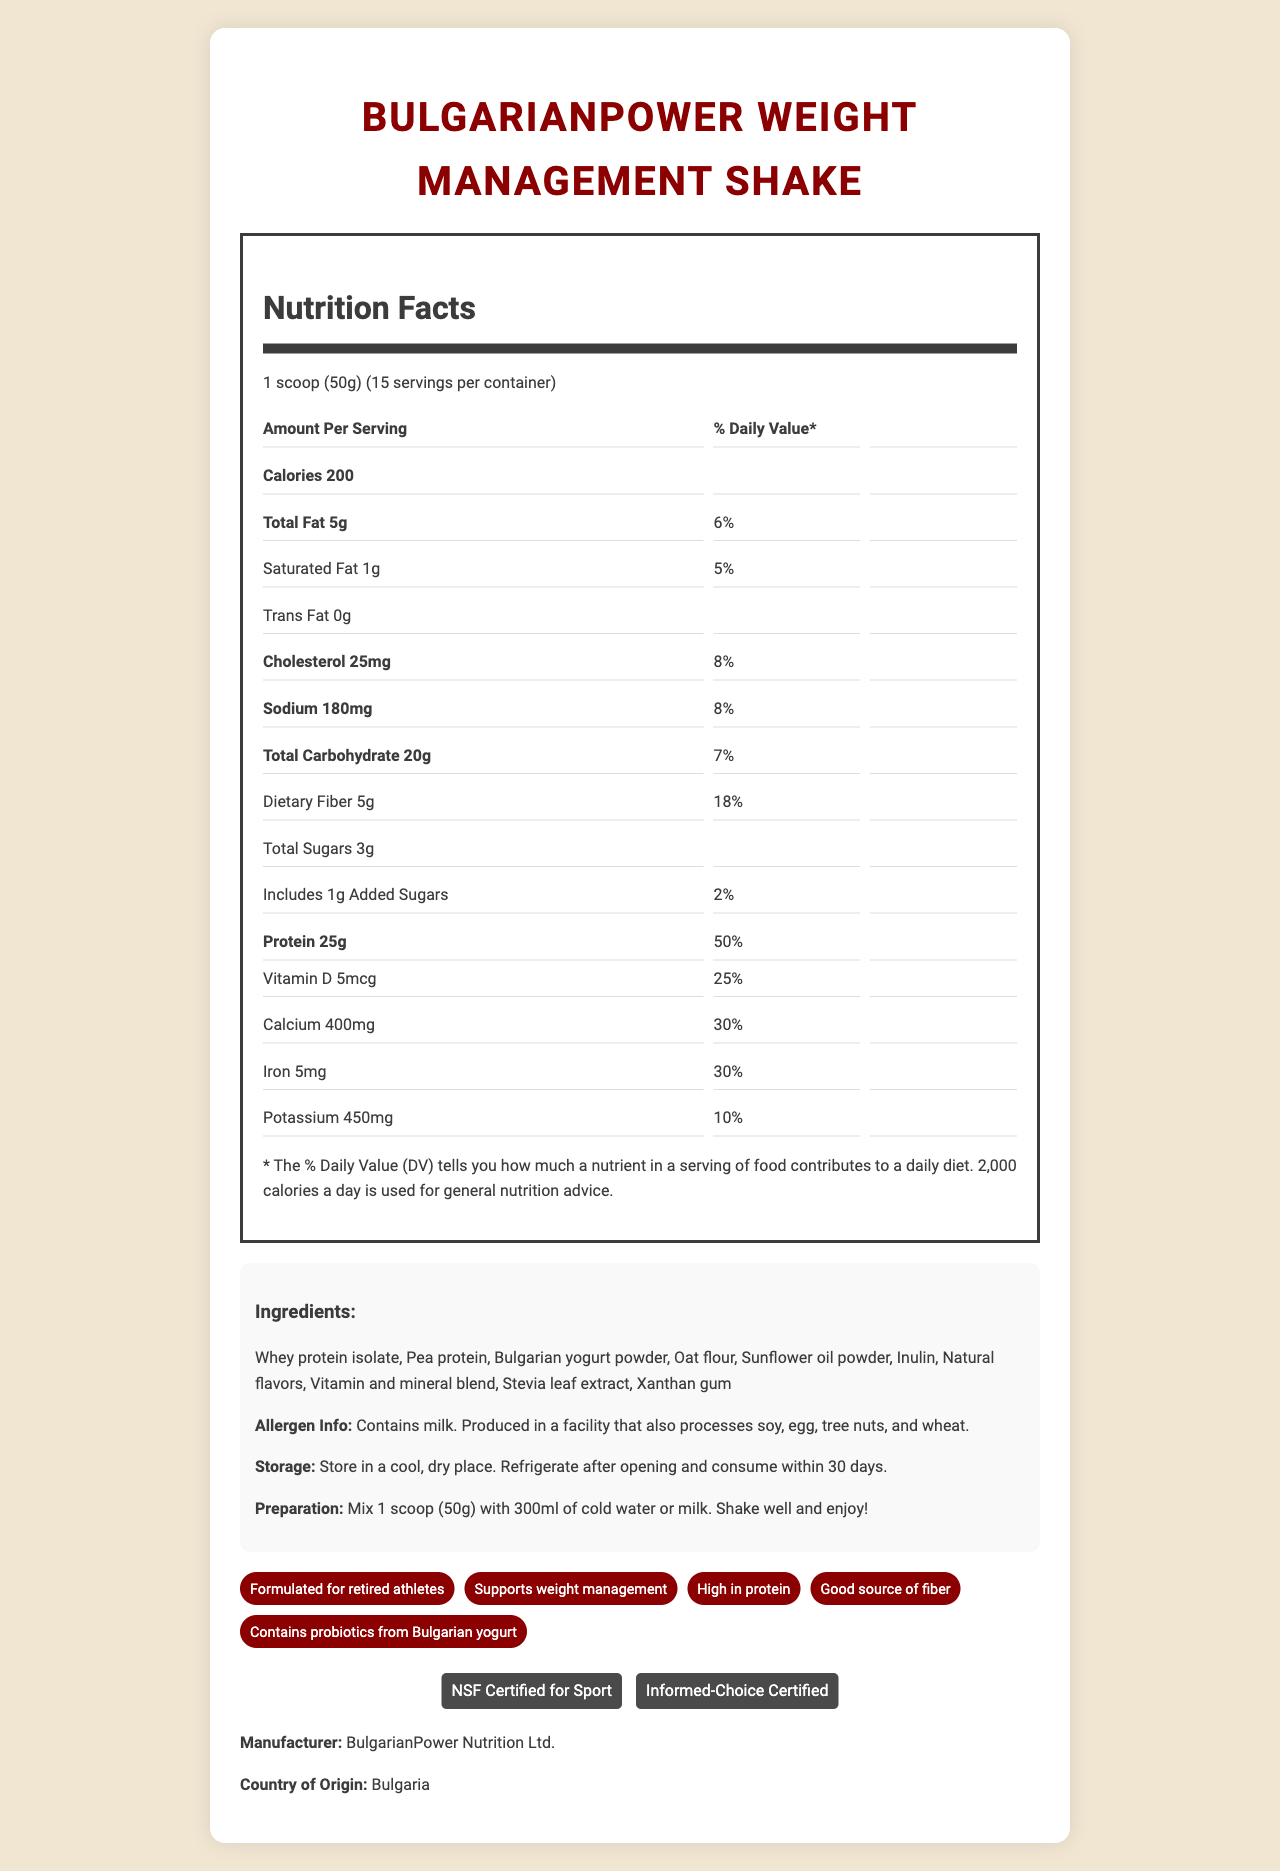what is the serving size? The serving size is specified at the top of the Nutrition Facts section: "1 scoop (50g)".
Answer: 1 scoop (50g) how many calories are there per serving? The amount of calories per serving is listed right below the "Amount Per Serving" header: "Calories 200".
Answer: 200 calories what percentage of the daily value does the protein amount to? It is written next to the protein amount in the Nutrition Facts: "Protein 25g  50%".
Answer: 50% which vitamins provide 50% of the daily value? These vitamins are listed in the lower part of the Nutrition Facts section with 50% daily value.
Answer: Vitamins A, C, E, K, Thiamin, Riboflavin, Niacin, Vitamin B6, Folate (200mcg DFE), Vitamin B12, Biotin, Pantothenic Acid, Iodine, Zinc, Selenium, Copper, Manganese, Chromium, Molybdenum what allergen information is provided? The allergen information is stated in the ingredients section: "Contains milk. Produced in a facility that also processes soy, egg, tree nuts, and wheat."
Answer: Contains milk. Produced in a facility that also processes soy, egg, tree nuts, and wheat. how should the product be prepared? A. Mix with hot water B. Mix with cold water or milk C. Microwave for 30 seconds The instructions state: "Mix 1 scoop (50g) with 300ml of cold water or milk. Shake well and enjoy!"
Answer: B where should the product be stored? A. In the refrigerator B. In the freezer C. In a cool, dry place The storage instructions specify: "Store in a cool, dry place. Refrigerate after opening and consume within 30 days."
Answer: C does this product support weight management? The product claims include "Supports weight management."
Answer: Yes is this nutritional supplement certified for sports? The claims section lists "NSF Certified for Sport" and "Informed-Choice Certified."
Answer: Yes summarize the document. The document includes comprehensive nutritional data, ingredients, allergen info, storage and preparation instructions, special claims, and certifications related to the BulgarianPower Weight Management Shake.
Answer: The document details the Nutrition Facts, ingredients, allergen information, storage and preparation instructions, product claims, and certifications for the BulgarianPower Weight Management Shake. The shake is formulated for retired athletes and supports weight management, being high in protein and fiber. It contains a variety of essential vitamins and minerals and is certified by NSF and Informed-Choice. how many servings are in each container? The number of servings per container is listed as "15" in the serving size information.
Answer: 15 servings where is the product manufactured? The manufacturer and country of origin are listed at the bottom of the document: "BulgarianPower Nutrition Ltd.", "Country of Origin: Bulgaria".
Answer: Bulgaria how much cholesterol is in each serving? The cholesterol content per serving is listed in the Nutrition Facts section: "Cholesterol 25mg".
Answer: 25mg what is the amount of fiber in one serving? A. 2g B. 3g C. 5g The dietary fiber content is stated in the Nutrition Facts: "Dietary Fiber 5g 18%."
Answer: C what is the country of origin? The bottom of the document lists the country of origin as "Bulgaria."
Answer: Bulgaria are there any artificial sweeteners in the ingredients? The ingredients list includes "Stevia leaf extract" which is a natural sweetener, but there is no specific mention of artificial sweeteners in the provided information.
Answer: Not enough information 